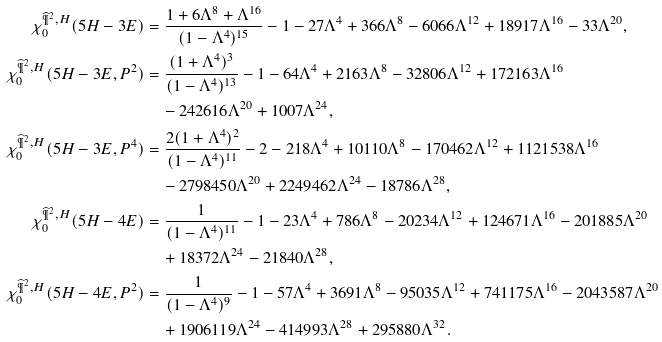<formula> <loc_0><loc_0><loc_500><loc_500>\chi ^ { \widehat { \P } ^ { 2 } , H } _ { 0 } ( 5 H - 3 E ) & = \frac { 1 + 6 \Lambda ^ { 8 } + \Lambda ^ { 1 6 } } { ( 1 - \Lambda ^ { 4 } ) ^ { 1 5 } } - 1 - 2 7 \Lambda ^ { 4 } + 3 6 6 \Lambda ^ { 8 } - 6 0 6 6 \Lambda ^ { 1 2 } + 1 8 9 1 7 \Lambda ^ { 1 6 } - 3 3 \Lambda ^ { 2 0 } , \\ \chi ^ { \widehat { \P } ^ { 2 } , H } _ { 0 } ( 5 H - 3 E , P ^ { 2 } ) & = \frac { ( 1 + \Lambda ^ { 4 } ) ^ { 3 } } { ( 1 - \Lambda ^ { 4 } ) ^ { 1 3 } } - 1 - 6 4 \Lambda ^ { 4 } + 2 1 6 3 \Lambda ^ { 8 } - 3 2 8 0 6 \Lambda ^ { 1 2 } + 1 7 2 1 6 3 \Lambda ^ { 1 6 } \\ & \quad - 2 4 2 6 1 6 \Lambda ^ { 2 0 } + 1 0 0 7 \Lambda ^ { 2 4 } , \\ \chi ^ { \widehat { \P } ^ { 2 } , H } _ { 0 } ( 5 H - 3 E , P ^ { 4 } ) & = \frac { 2 ( 1 + \Lambda ^ { 4 } ) ^ { 2 } } { ( 1 - \Lambda ^ { 4 } ) ^ { 1 1 } } - 2 - 2 1 8 \Lambda ^ { 4 } + 1 0 1 1 0 \Lambda ^ { 8 } - 1 7 0 4 6 2 \Lambda ^ { 1 2 } + 1 1 2 1 5 3 8 \Lambda ^ { 1 6 } \\ & \quad - 2 7 9 8 4 5 0 \Lambda ^ { 2 0 } + 2 2 4 9 4 6 2 \Lambda ^ { 2 4 } - 1 8 7 8 6 \Lambda ^ { 2 8 } , \\ \chi ^ { \widehat { \P } ^ { 2 } , H } _ { 0 } ( 5 H - 4 E ) & = \frac { 1 } { ( 1 - \Lambda ^ { 4 } ) ^ { 1 1 } } - 1 - 2 3 \Lambda ^ { 4 } + 7 8 6 \Lambda ^ { 8 } - 2 0 2 3 4 \Lambda ^ { 1 2 } + 1 2 4 6 7 1 \Lambda ^ { 1 6 } - 2 0 1 8 8 5 \Lambda ^ { 2 0 } \\ & \quad + 1 8 3 7 2 \Lambda ^ { 2 4 } - 2 1 8 4 0 \Lambda ^ { 2 8 } , \\ \chi ^ { \widehat { \P } ^ { 2 } , H } _ { 0 } ( 5 H - 4 E , P ^ { 2 } ) & = \frac { 1 } { ( 1 - \Lambda ^ { 4 } ) ^ { 9 } } - 1 - 5 7 \Lambda ^ { 4 } + 3 6 9 1 \Lambda ^ { 8 } - 9 5 0 3 5 \Lambda ^ { 1 2 } + 7 4 1 1 7 5 \Lambda ^ { 1 6 } - 2 0 4 3 5 8 7 \Lambda ^ { 2 0 } \\ & \quad + 1 9 0 6 1 1 9 \Lambda ^ { 2 4 } - 4 1 4 9 9 3 \Lambda ^ { 2 8 } + 2 9 5 8 8 0 \Lambda ^ { 3 2 } .</formula> 